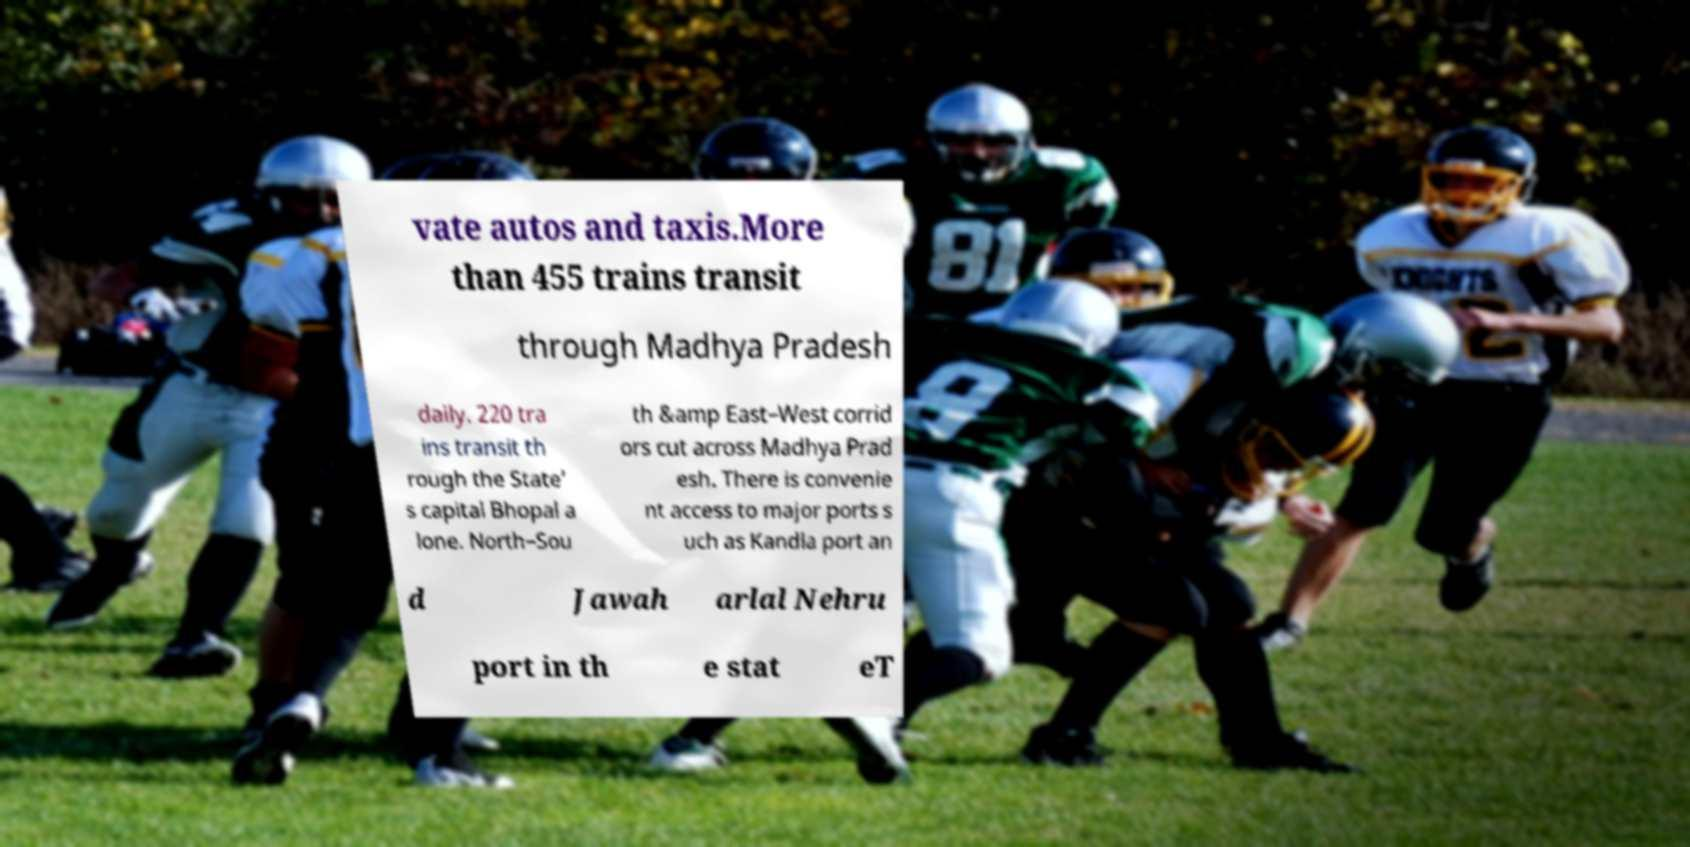Could you extract and type out the text from this image? vate autos and taxis.More than 455 trains transit through Madhya Pradesh daily. 220 tra ins transit th rough the State’ s capital Bhopal a lone. North–Sou th &amp East–West corrid ors cut across Madhya Prad esh. There is convenie nt access to major ports s uch as Kandla port an d Jawah arlal Nehru port in th e stat eT 